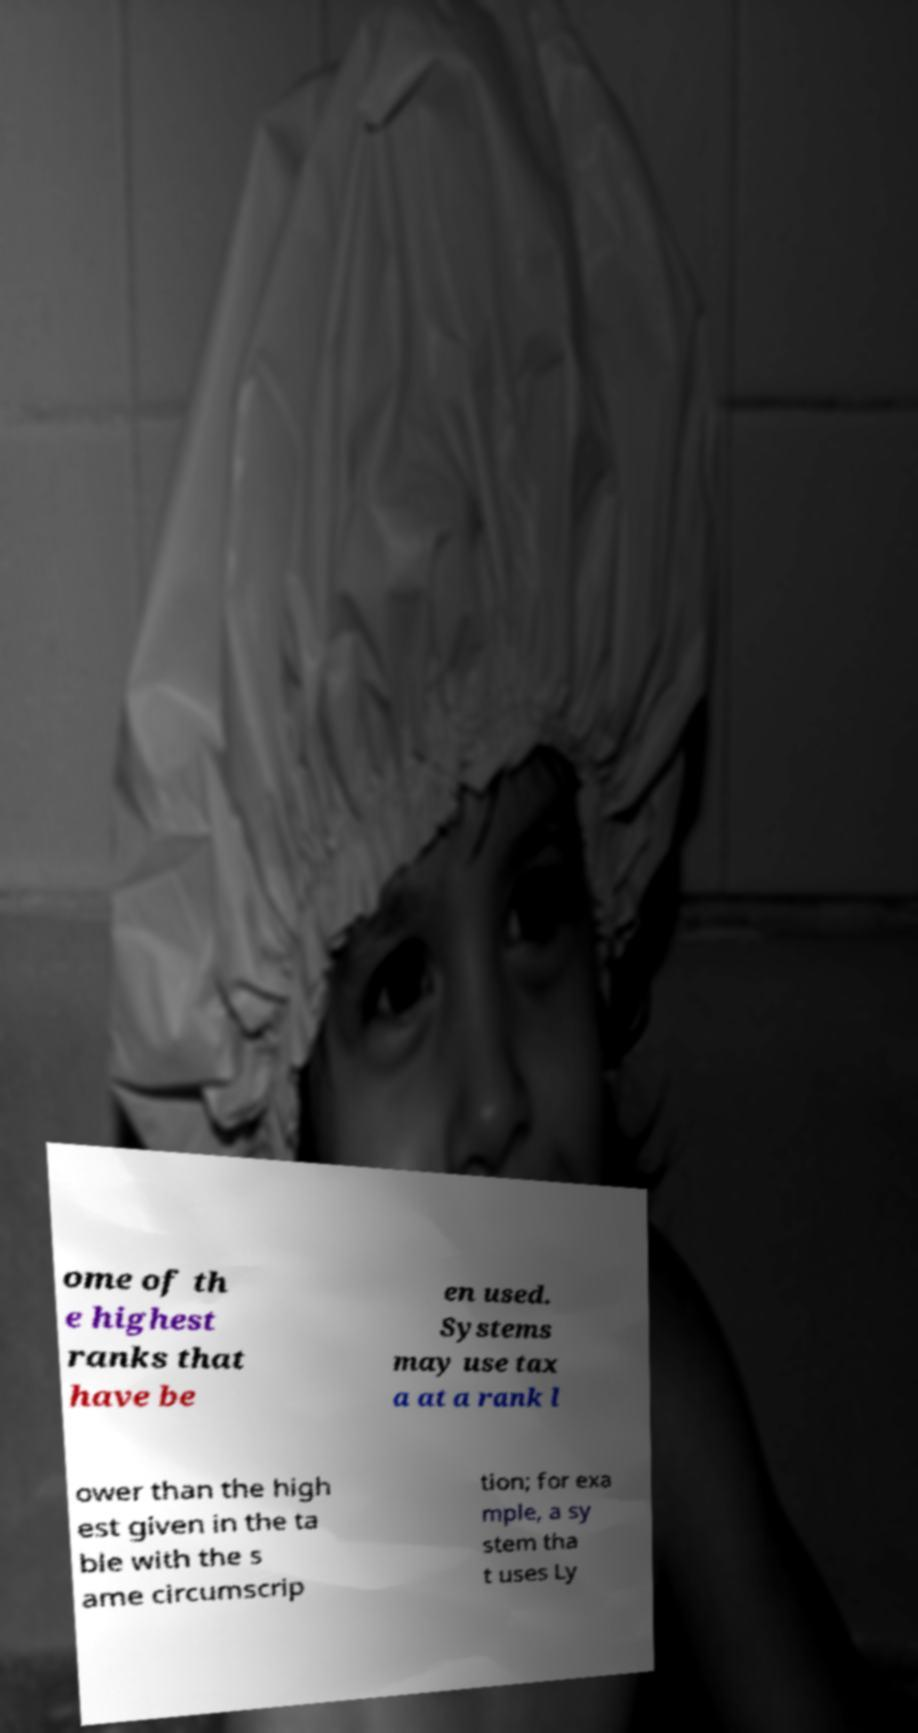Could you assist in decoding the text presented in this image and type it out clearly? ome of th e highest ranks that have be en used. Systems may use tax a at a rank l ower than the high est given in the ta ble with the s ame circumscrip tion; for exa mple, a sy stem tha t uses Ly 